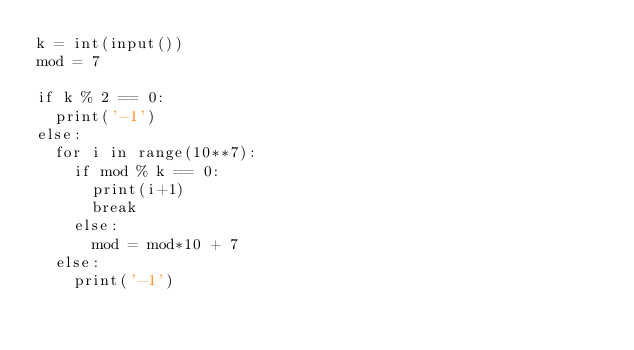<code> <loc_0><loc_0><loc_500><loc_500><_Python_>k = int(input())
mod = 7

if k % 2 == 0:
  print('-1')
else:
  for i in range(10**7):
    if mod % k == 0:
      print(i+1)
      break
    else:
      mod = mod*10 + 7
  else:
    print('-1')</code> 